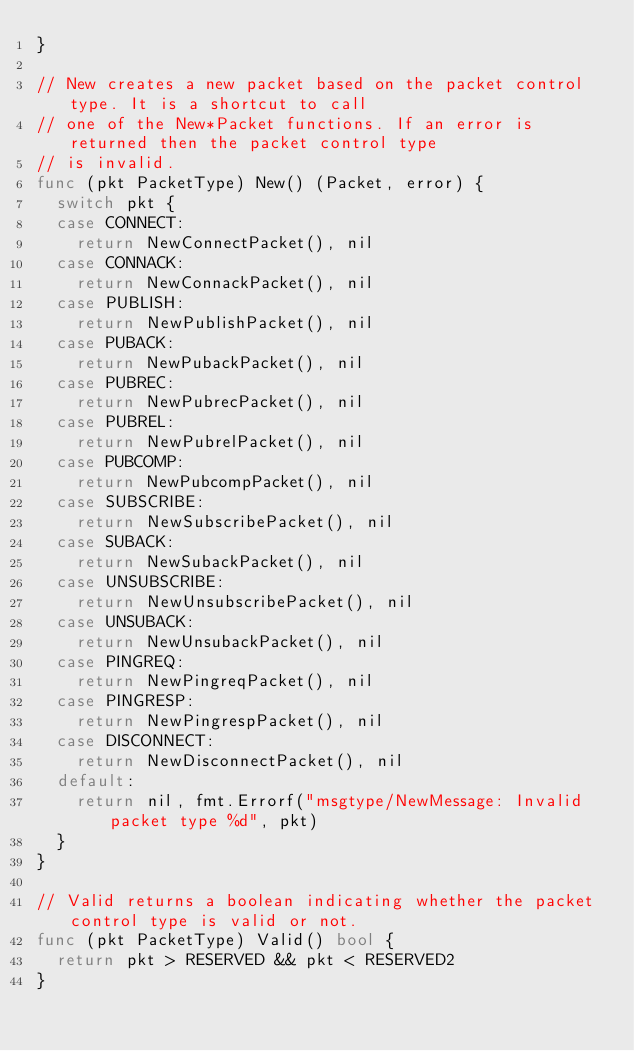Convert code to text. <code><loc_0><loc_0><loc_500><loc_500><_Go_>}

// New creates a new packet based on the packet control type. It is a shortcut to call
// one of the New*Packet functions. If an error is returned then the packet control type
// is invalid.
func (pkt PacketType) New() (Packet, error) {
	switch pkt {
	case CONNECT:
		return NewConnectPacket(), nil
	case CONNACK:
		return NewConnackPacket(), nil
	case PUBLISH:
		return NewPublishPacket(), nil
	case PUBACK:
		return NewPubackPacket(), nil
	case PUBREC:
		return NewPubrecPacket(), nil
	case PUBREL:
		return NewPubrelPacket(), nil
	case PUBCOMP:
		return NewPubcompPacket(), nil
	case SUBSCRIBE:
		return NewSubscribePacket(), nil
	case SUBACK:
		return NewSubackPacket(), nil
	case UNSUBSCRIBE:
		return NewUnsubscribePacket(), nil
	case UNSUBACK:
		return NewUnsubackPacket(), nil
	case PINGREQ:
		return NewPingreqPacket(), nil
	case PINGRESP:
		return NewPingrespPacket(), nil
	case DISCONNECT:
		return NewDisconnectPacket(), nil
	default:
		return nil, fmt.Errorf("msgtype/NewMessage: Invalid packet type %d", pkt)
	}
}

// Valid returns a boolean indicating whether the packet control type is valid or not.
func (pkt PacketType) Valid() bool {
	return pkt > RESERVED && pkt < RESERVED2
}
</code> 